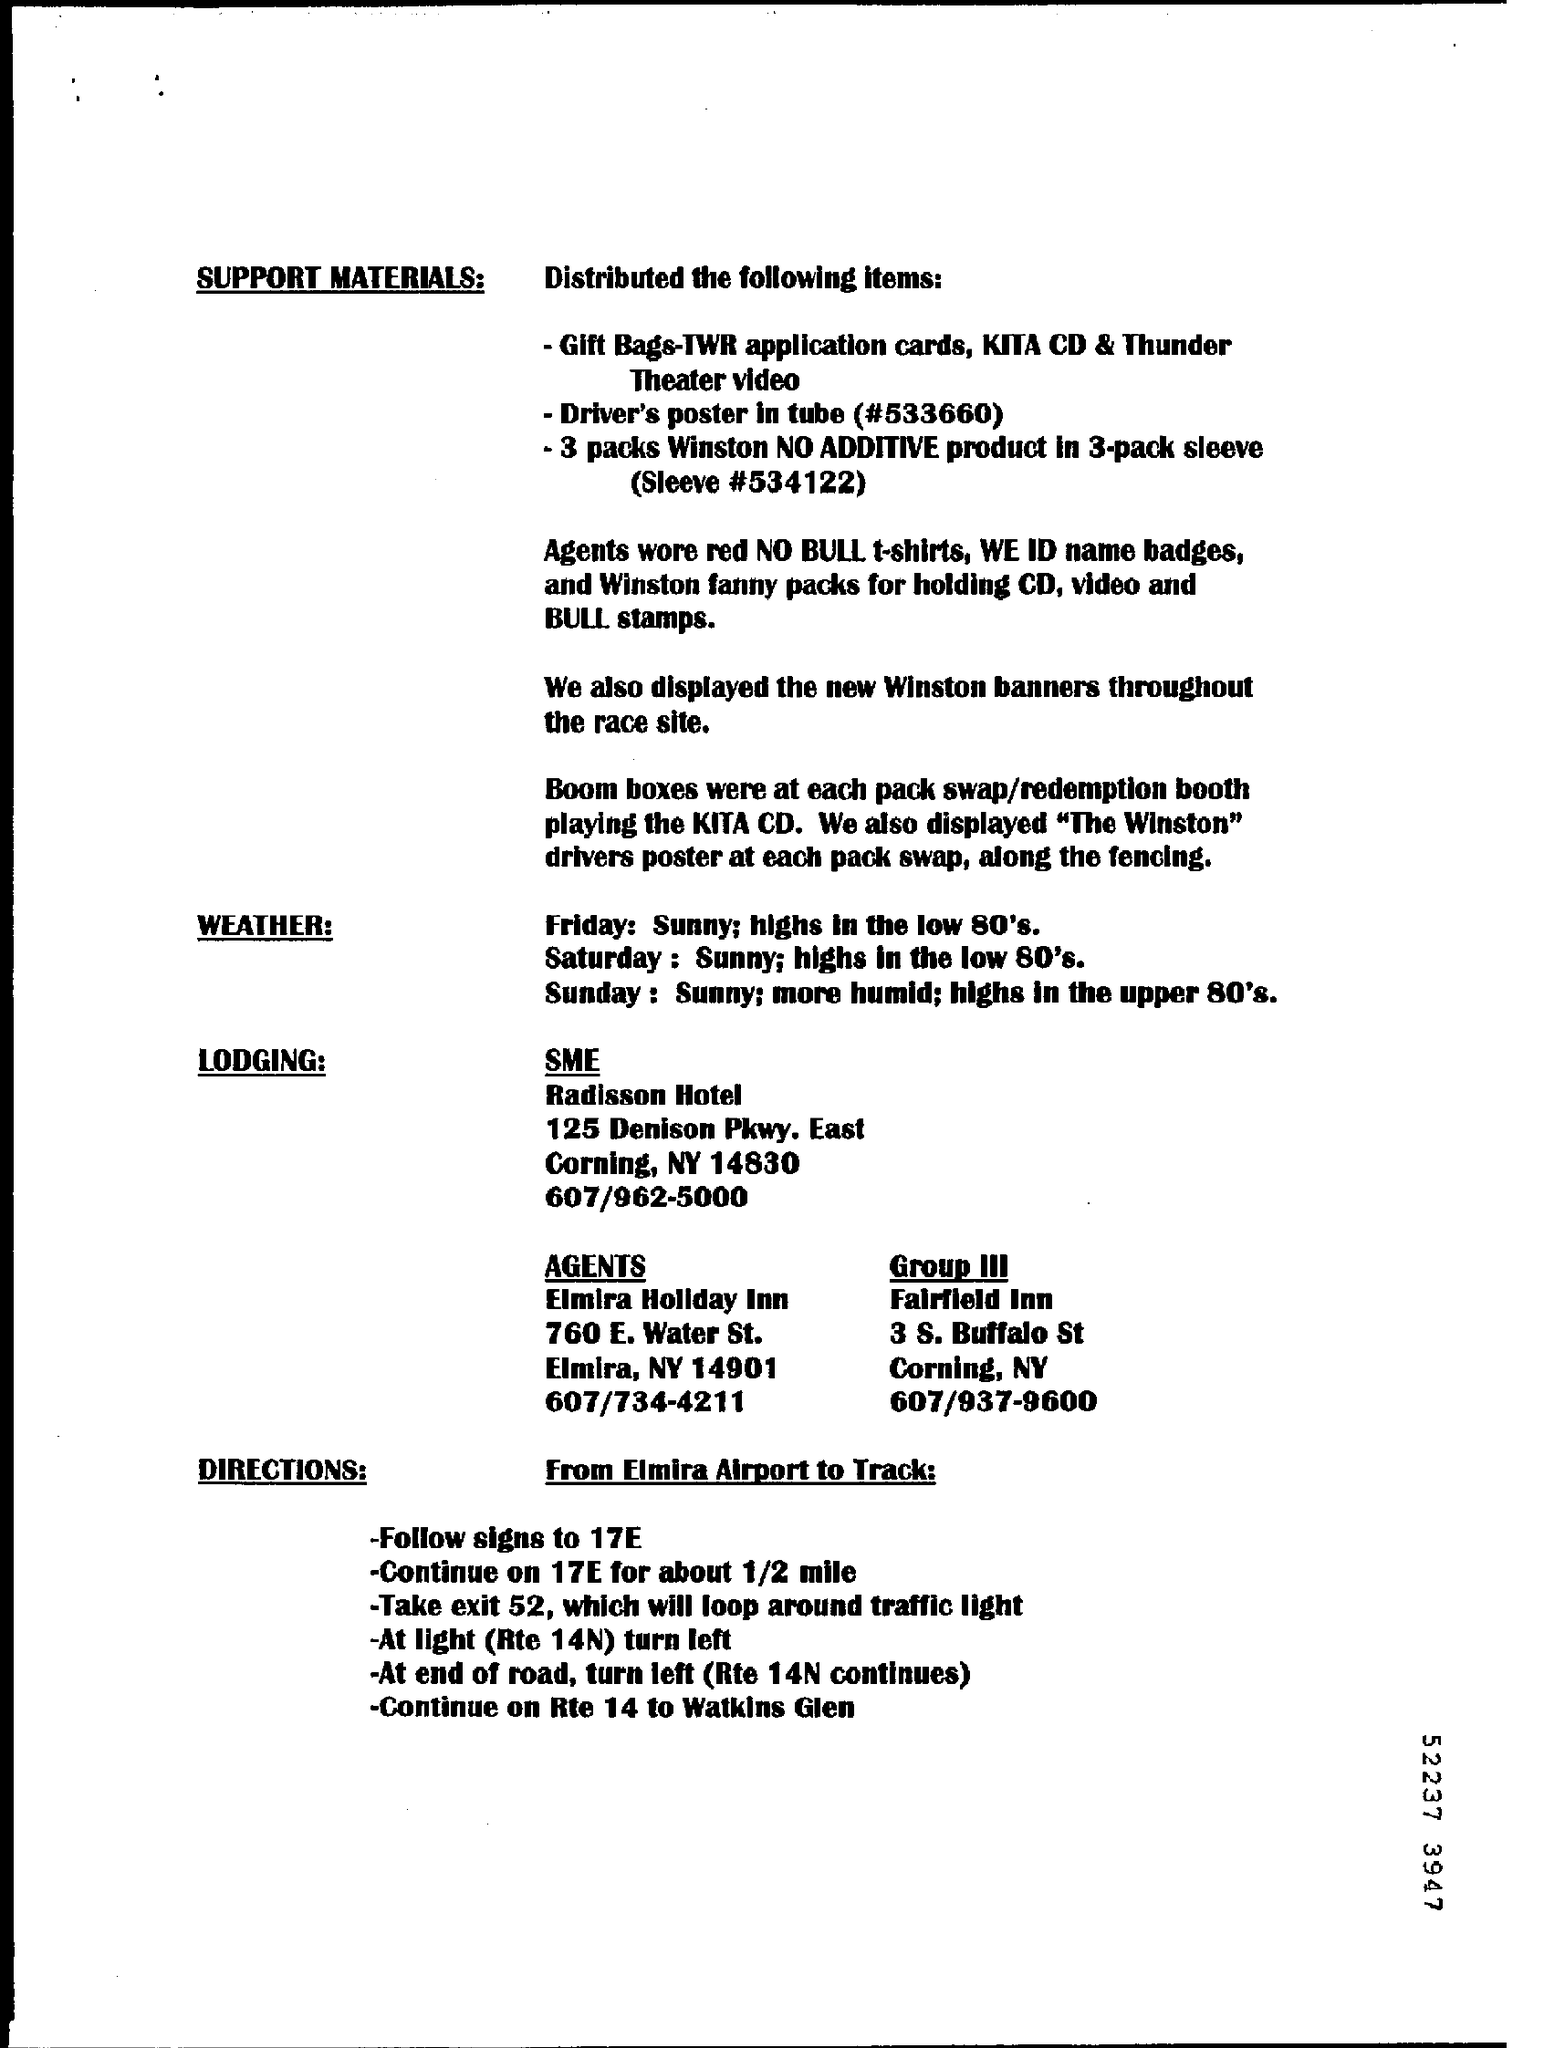Draw attention to some important aspects in this diagram. What kind of new banners were displayed through the Race site? The answer is Winston. 